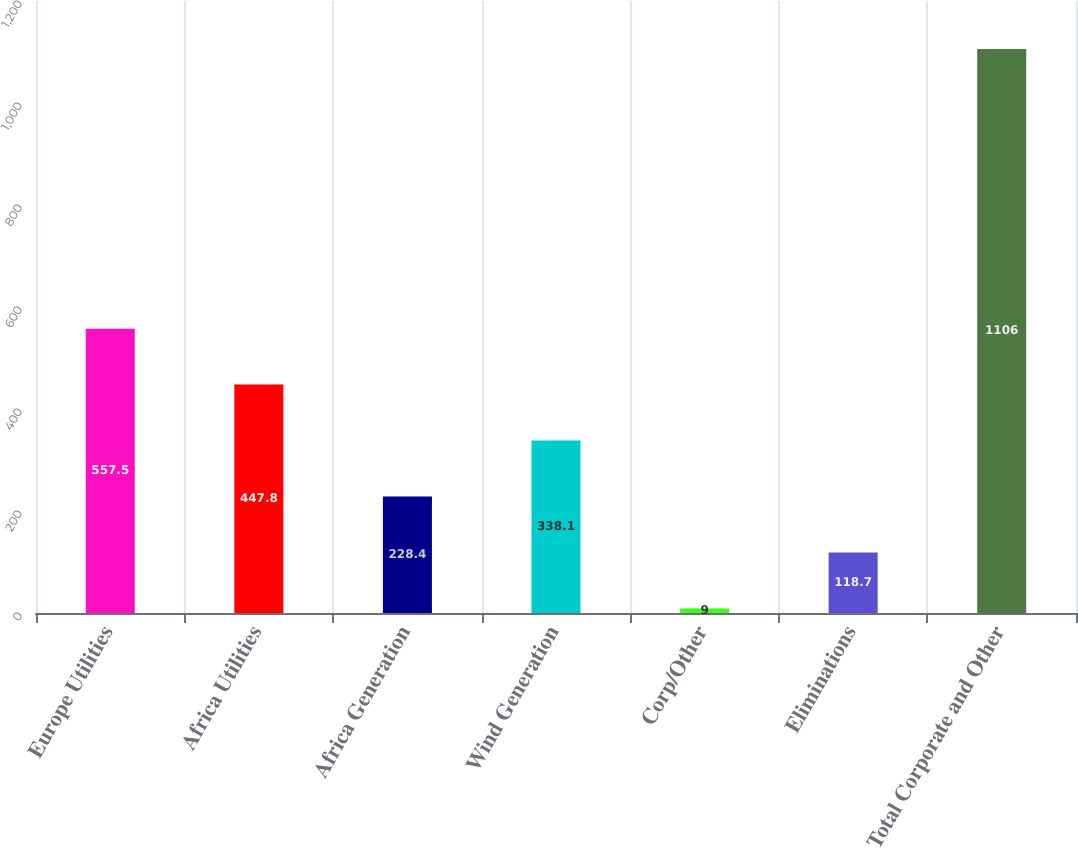<chart> <loc_0><loc_0><loc_500><loc_500><bar_chart><fcel>Europe Utilities<fcel>Africa Utilities<fcel>Africa Generation<fcel>Wind Generation<fcel>Corp/Other<fcel>Eliminations<fcel>Total Corporate and Other<nl><fcel>557.5<fcel>447.8<fcel>228.4<fcel>338.1<fcel>9<fcel>118.7<fcel>1106<nl></chart> 